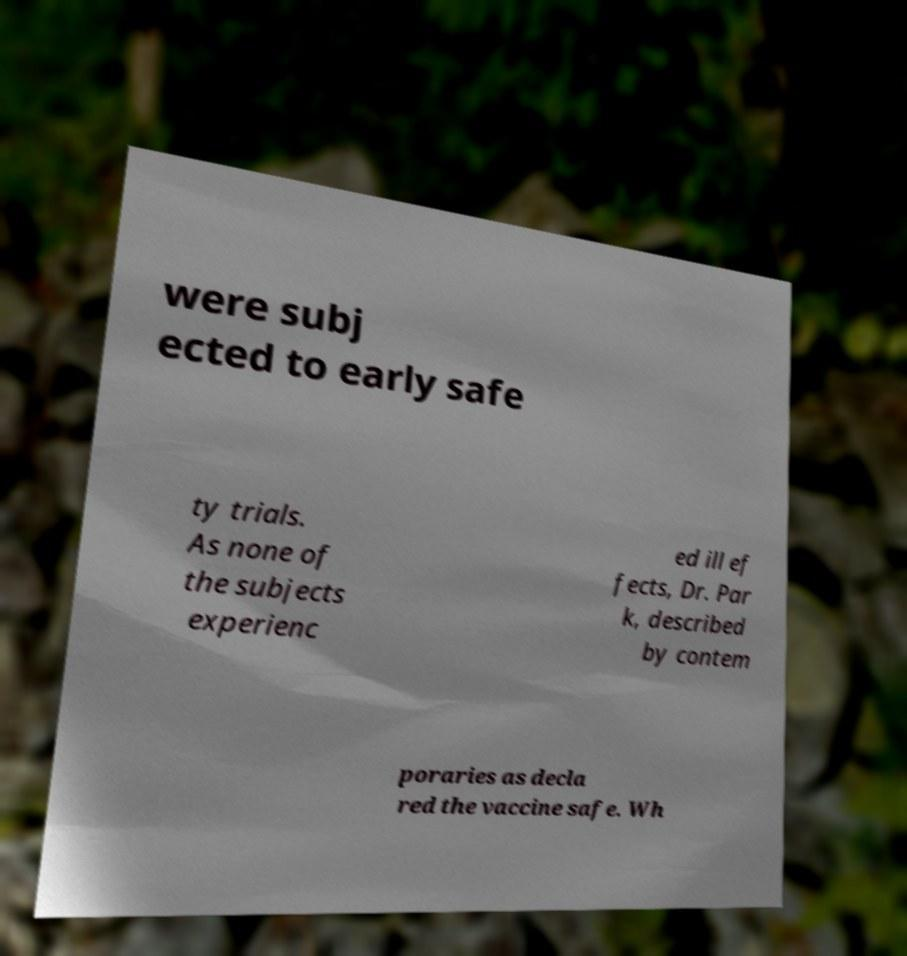I need the written content from this picture converted into text. Can you do that? were subj ected to early safe ty trials. As none of the subjects experienc ed ill ef fects, Dr. Par k, described by contem poraries as decla red the vaccine safe. Wh 